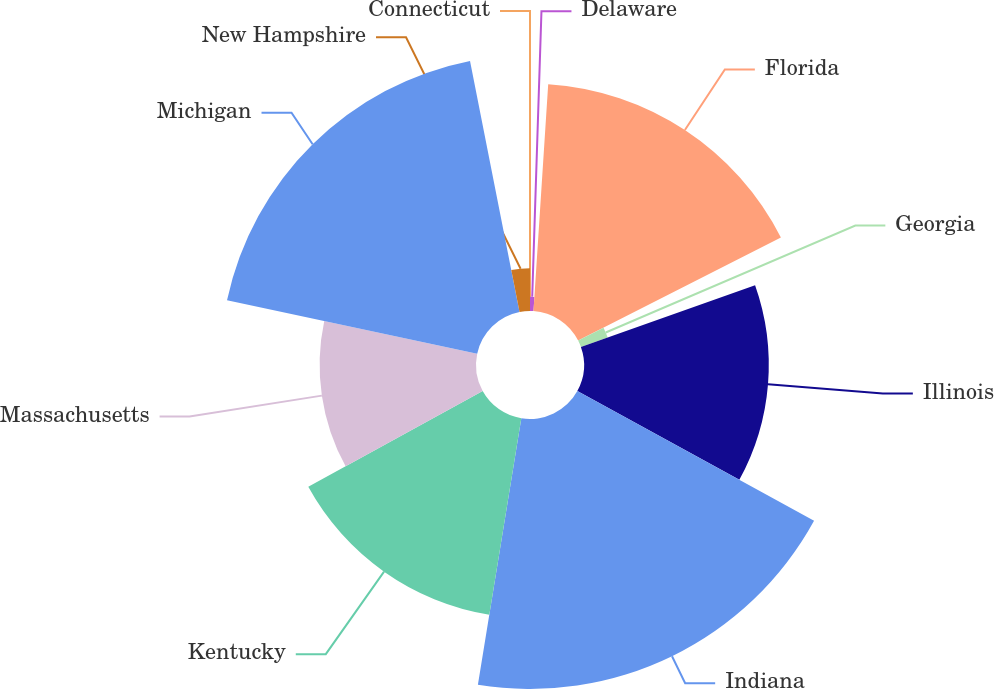Convert chart. <chart><loc_0><loc_0><loc_500><loc_500><pie_chart><fcel>Connecticut<fcel>Delaware<fcel>Florida<fcel>Georgia<fcel>Illinois<fcel>Indiana<fcel>Kentucky<fcel>Massachusetts<fcel>Michigan<fcel>New Hampshire<nl><fcel>0.0%<fcel>1.03%<fcel>16.49%<fcel>2.06%<fcel>13.4%<fcel>19.58%<fcel>14.43%<fcel>11.34%<fcel>18.55%<fcel>3.1%<nl></chart> 